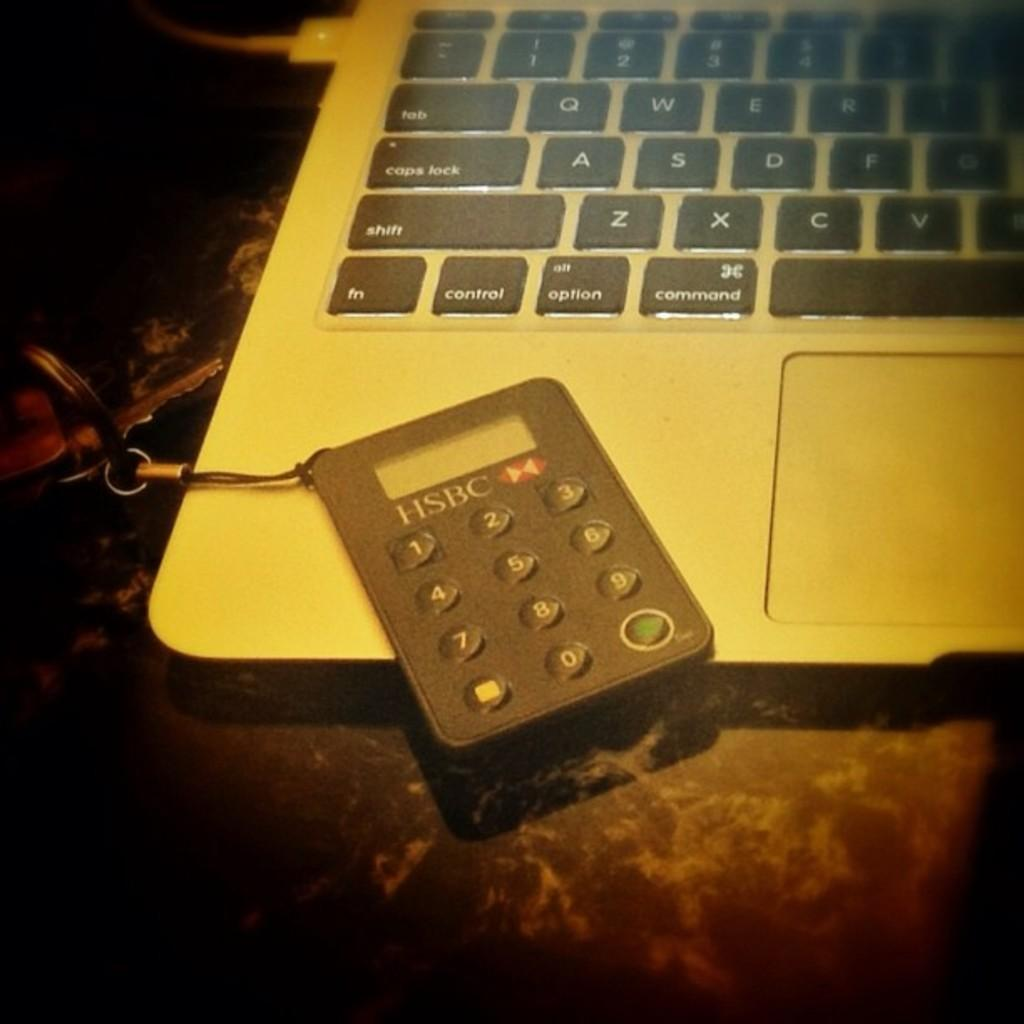<image>
Offer a succinct explanation of the picture presented. A small pocket calculator is made by the HSBC company. 